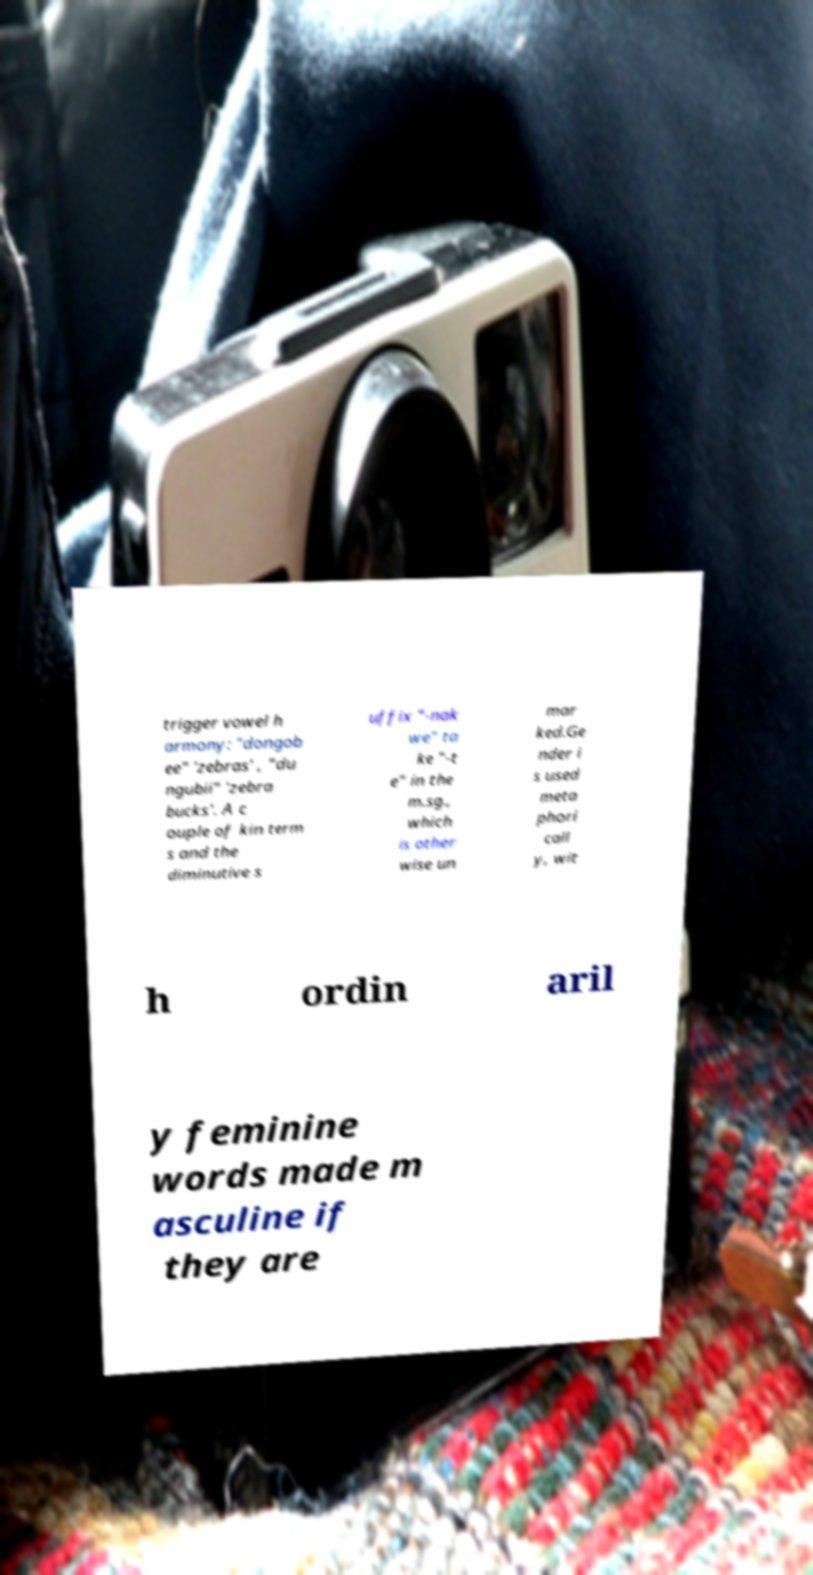For documentation purposes, I need the text within this image transcribed. Could you provide that? trigger vowel h armony: "dongob ee" 'zebras' , "du ngubii" 'zebra bucks'. A c ouple of kin term s and the diminutive s uffix "-nak we" ta ke "-t e" in the m.sg., which is other wise un mar ked.Ge nder i s used meta phori call y, wit h ordin aril y feminine words made m asculine if they are 